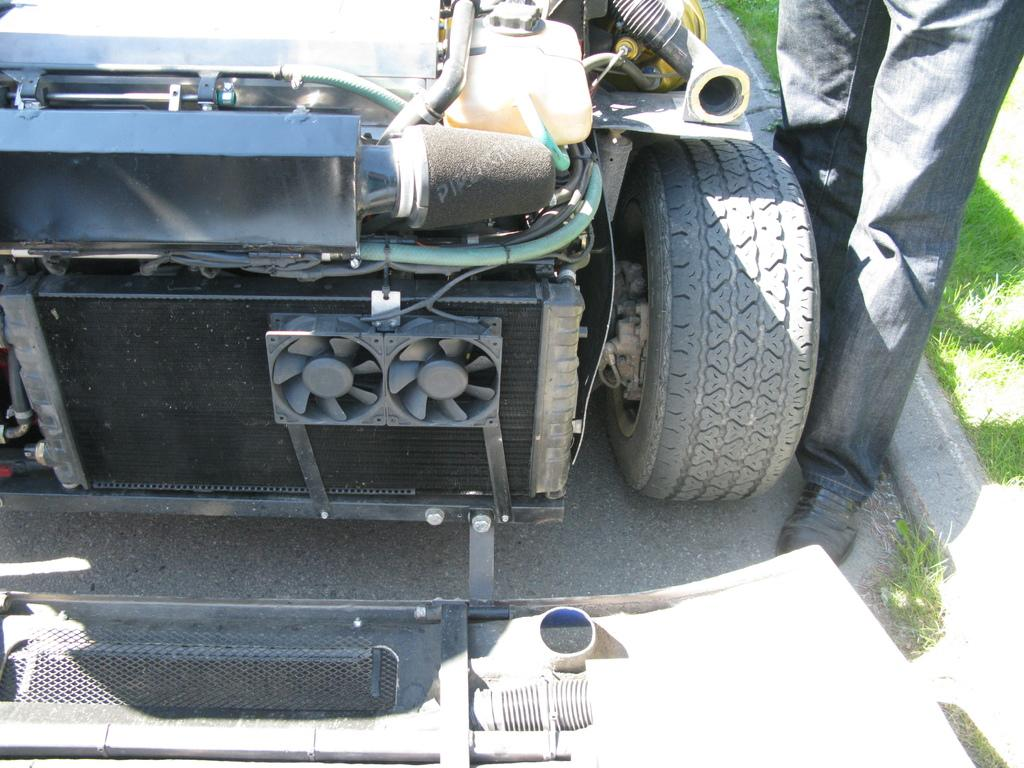What is located on the left side of the image? There is a vehicle on the left side of the image. What objects can be seen in the middle of the image? There are two fans in the middle of the image. Can you describe the person on the right side of the image? There is a person on the right side of the image. What type of vegetation is present in the image? Grass is present in the image. What type of flag is being waved by the person in the image? There is no flag present in the image; only a vehicle, two fans, a person, and grass are visible. Can you tell me how many stems are attached to the person in the image? There are no stems attached to the person in the image. 